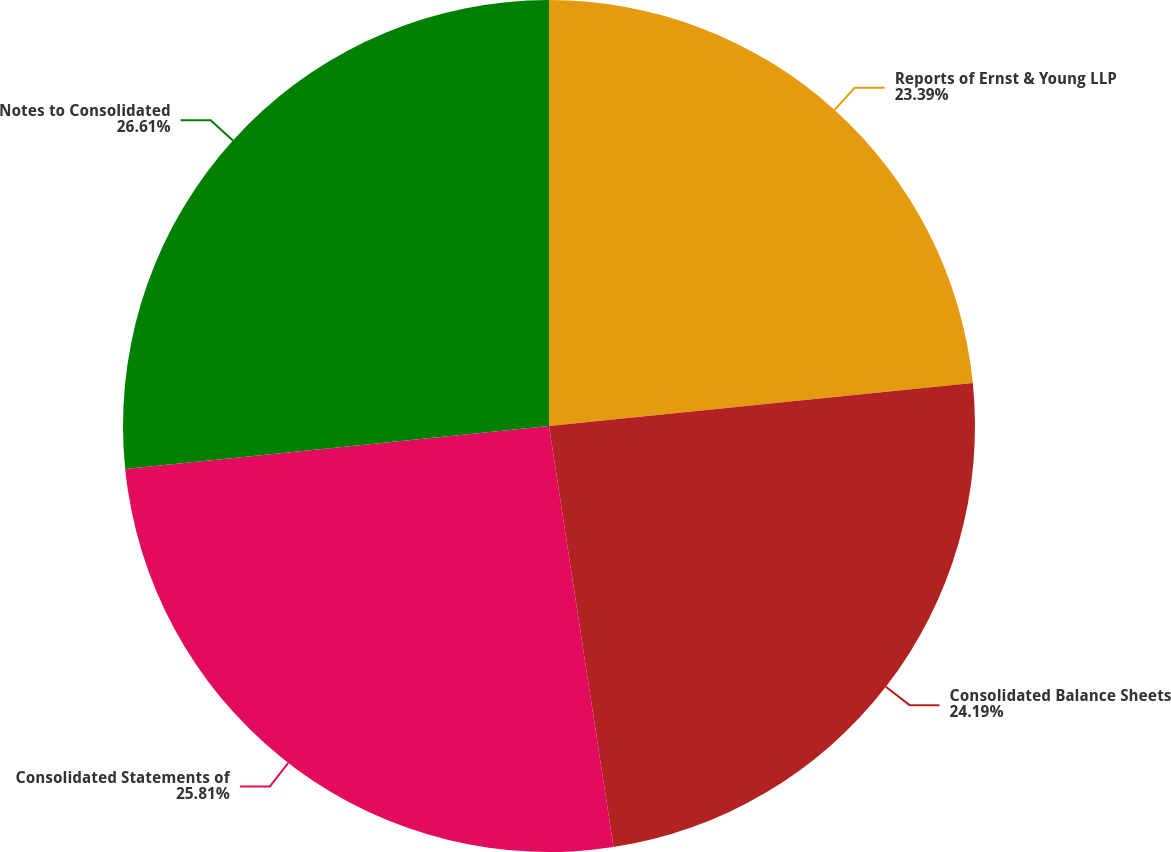<chart> <loc_0><loc_0><loc_500><loc_500><pie_chart><fcel>Reports of Ernst & Young LLP<fcel>Consolidated Balance Sheets<fcel>Consolidated Statements of<fcel>Notes to Consolidated<nl><fcel>23.39%<fcel>24.19%<fcel>25.81%<fcel>26.61%<nl></chart> 